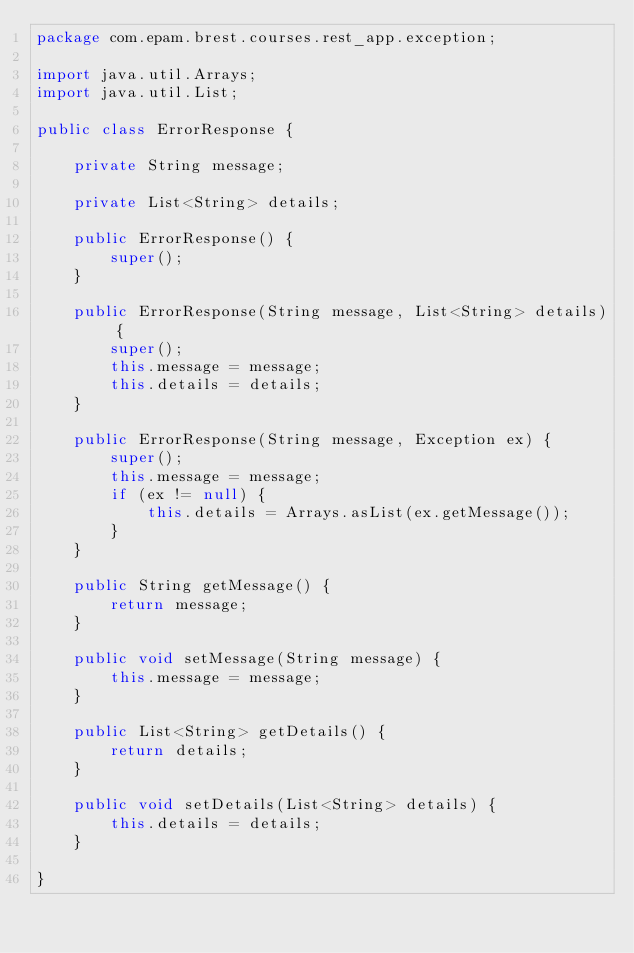<code> <loc_0><loc_0><loc_500><loc_500><_Java_>package com.epam.brest.courses.rest_app.exception;

import java.util.Arrays;
import java.util.List;

public class ErrorResponse {

    private String message;

    private List<String> details;

    public ErrorResponse() {
        super();
    }

    public ErrorResponse(String message, List<String> details) {
        super();
        this.message = message;
        this.details = details;
    }

    public ErrorResponse(String message, Exception ex) {
        super();
        this.message = message;
        if (ex != null) {
            this.details = Arrays.asList(ex.getMessage());
        }
    }

    public String getMessage() {
        return message;
    }

    public void setMessage(String message) {
        this.message = message;
    }

    public List<String> getDetails() {
        return details;
    }

    public void setDetails(List<String> details) {
        this.details = details;
    }

}</code> 